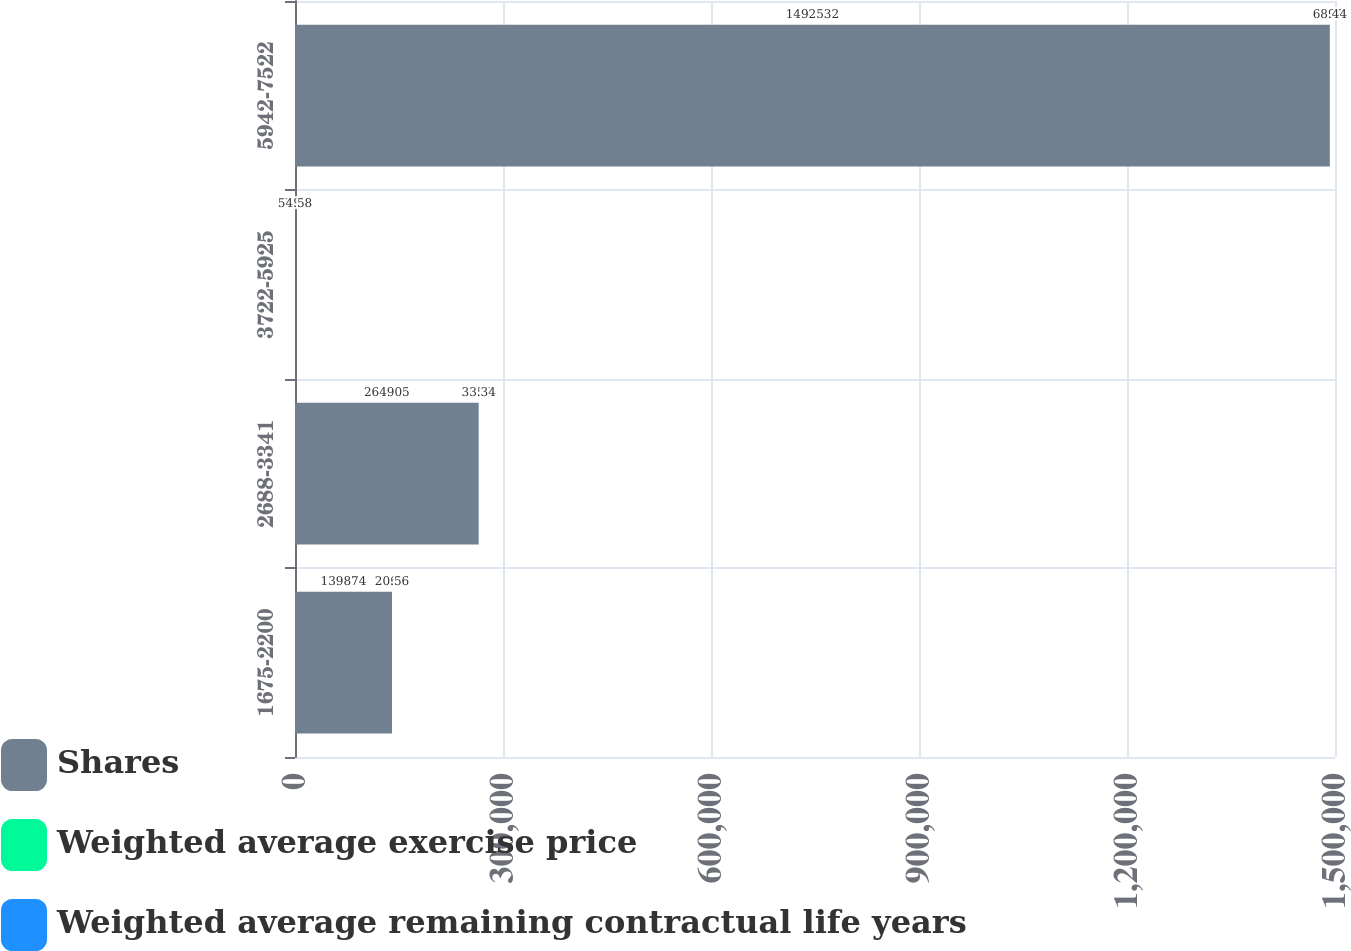Convert chart. <chart><loc_0><loc_0><loc_500><loc_500><stacked_bar_chart><ecel><fcel>1675-2200<fcel>2688-3341<fcel>3722-5925<fcel>5942-7522<nl><fcel>Shares<fcel>139874<fcel>264905<fcel>33.34<fcel>1.49253e+06<nl><fcel>Weighted average exercise price<fcel>3.66<fcel>4.56<fcel>7.85<fcel>7.97<nl><fcel>Weighted average remaining contractual life years<fcel>20.56<fcel>33.34<fcel>54.58<fcel>68.44<nl></chart> 